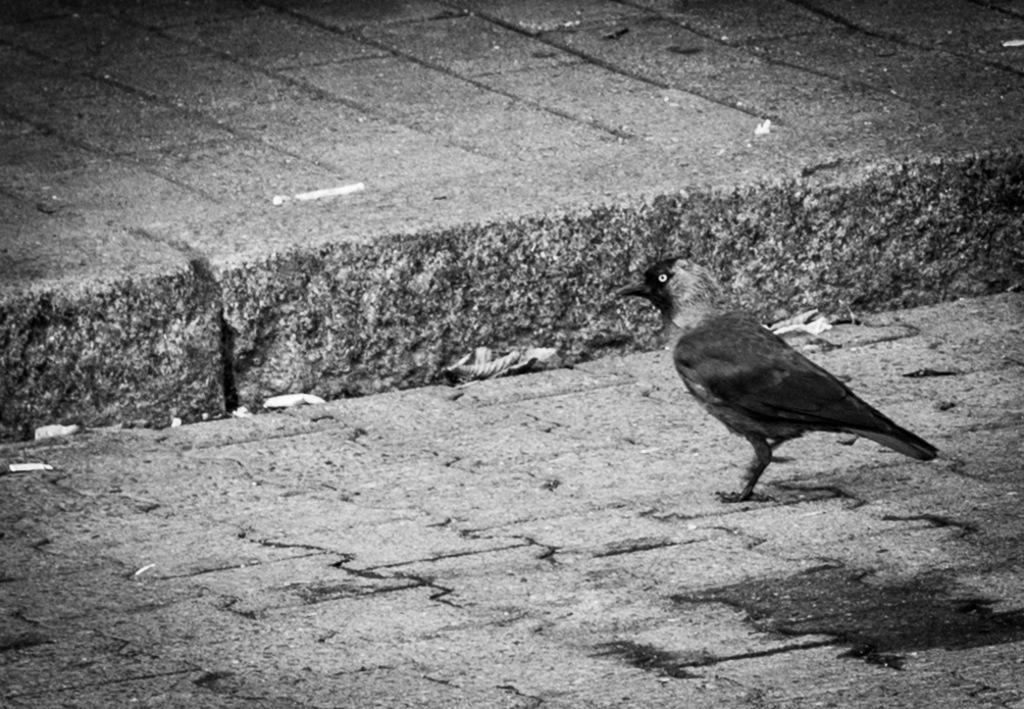What type of animal is present in the image? There is a bird in the image. Where is the bird located? The bird is on the road. What is the color scheme of the image? The image is black and white. What theory does the bird have about friction in the image? There is no indication in the image that the bird has any theory about friction, as birds do not typically engage in theoretical discussions. 